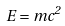<formula> <loc_0><loc_0><loc_500><loc_500>E = m c ^ { 2 }</formula> 